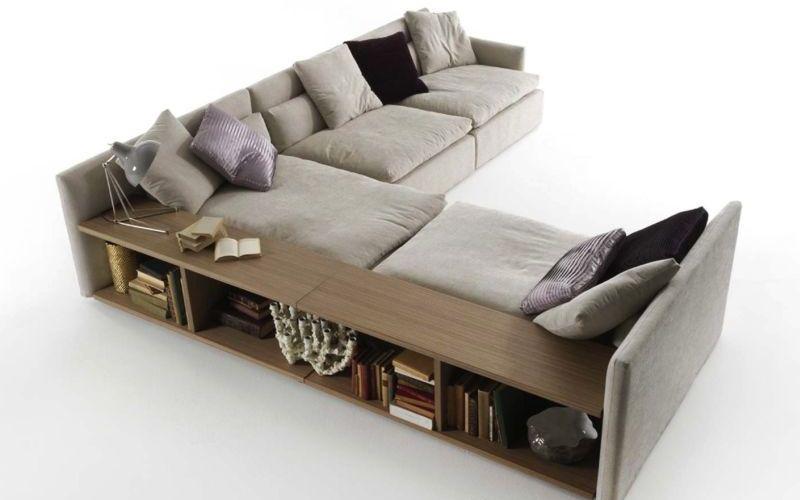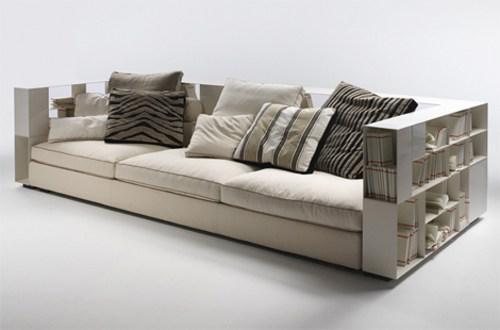The first image is the image on the left, the second image is the image on the right. Assess this claim about the two images: "A black bookshelf sits against the wall in one of the images.". Correct or not? Answer yes or no. No. The first image is the image on the left, the second image is the image on the right. For the images displayed, is the sentence "An image shows a sofa with neutral ecru cushions and bookshelves built into the sides." factually correct? Answer yes or no. Yes. 